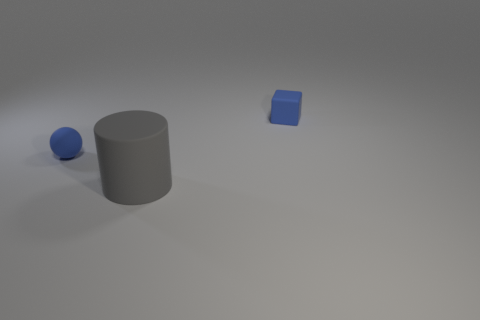Add 1 small blue shiny cylinders. How many objects exist? 4 Subtract all cylinders. How many objects are left? 2 Subtract all large purple rubber cylinders. Subtract all large rubber cylinders. How many objects are left? 2 Add 3 tiny blue rubber balls. How many tiny blue rubber balls are left? 4 Add 2 red objects. How many red objects exist? 2 Subtract 1 blue balls. How many objects are left? 2 